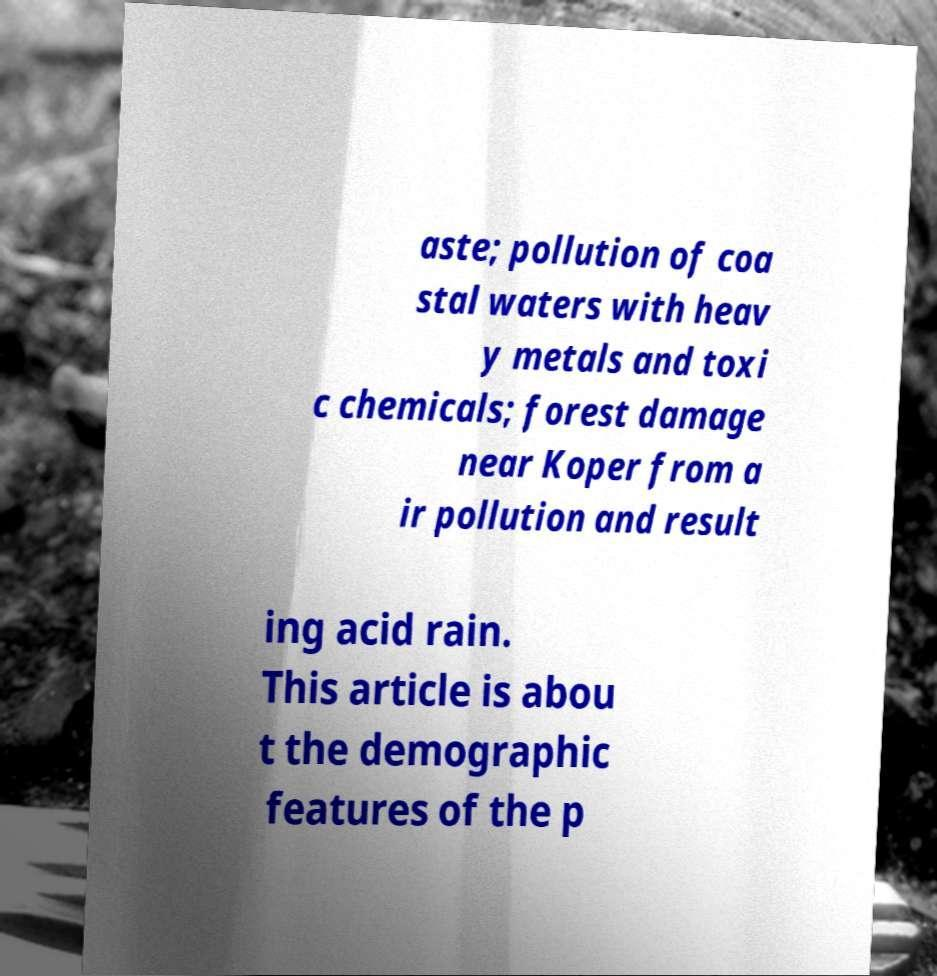Please read and relay the text visible in this image. What does it say? aste; pollution of coa stal waters with heav y metals and toxi c chemicals; forest damage near Koper from a ir pollution and result ing acid rain. This article is abou t the demographic features of the p 